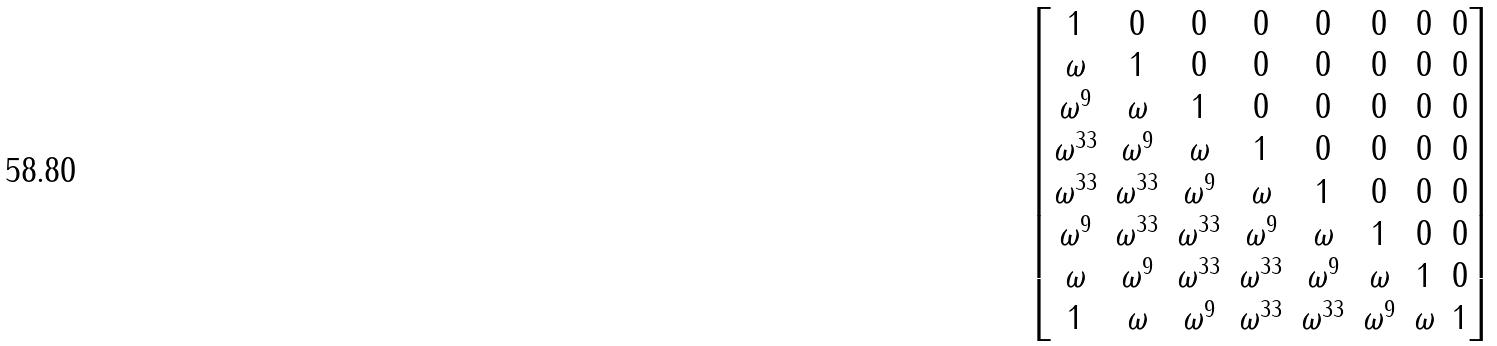<formula> <loc_0><loc_0><loc_500><loc_500>\begin{bmatrix} 1 & 0 & 0 & 0 & 0 & 0 & 0 & 0 \\ \omega & 1 & 0 & 0 & 0 & 0 & 0 & 0 \\ \omega ^ { 9 } & \omega & 1 & 0 & 0 & 0 & 0 & 0 \\ \omega ^ { 3 3 } & \omega ^ { 9 } & \omega & 1 & 0 & 0 & 0 & 0 \\ \omega ^ { 3 3 } & \omega ^ { 3 3 } & \omega ^ { 9 } & \omega & 1 & 0 & 0 & 0 \\ \omega ^ { 9 } & \omega ^ { 3 3 } & \omega ^ { 3 3 } & \omega ^ { 9 } & \omega & 1 & 0 & 0 \\ \omega & \omega ^ { 9 } & \omega ^ { 3 3 } & \omega ^ { 3 3 } & \omega ^ { 9 } & \omega & 1 & 0 \\ 1 & \omega & \omega ^ { 9 } & \omega ^ { 3 3 } & \omega ^ { 3 3 } & \omega ^ { 9 } & \omega & 1 \end{bmatrix}</formula> 